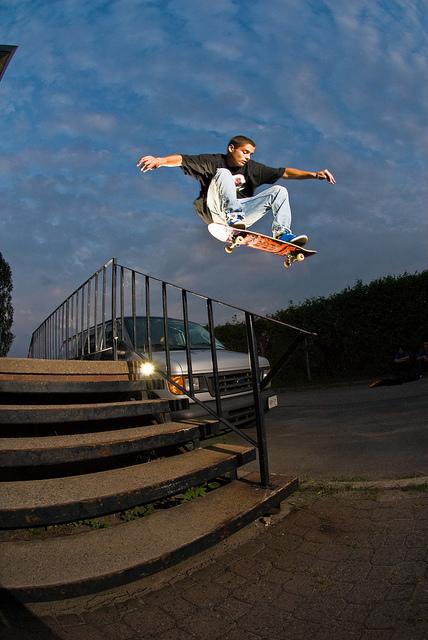What color is the rail?
Give a very brief answer. Black. How many steps is the guy jumping over?
Short answer required. 5. Could this be a skateboard park?
Answer briefly. No. What color is the skateboard?
Give a very brief answer. Orange. Is the boy's shadow visible?
Answer briefly. No. What type of shirt is this boy wearing?
Write a very short answer. T shirt. How high is he flying?
Quick response, please. High. What caused the shadow?
Answer briefly. Skateboard. What is the boy riding on?
Concise answer only. Skateboard. Where is he?
Write a very short answer. Outside. How many stairs are there?
Concise answer only. 5. How many kids in the picture?
Be succinct. 1. What is in the air?
Answer briefly. Skateboarder. What color is his shirt?
Give a very brief answer. Black. 